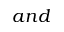<formula> <loc_0><loc_0><loc_500><loc_500>a n d</formula> 